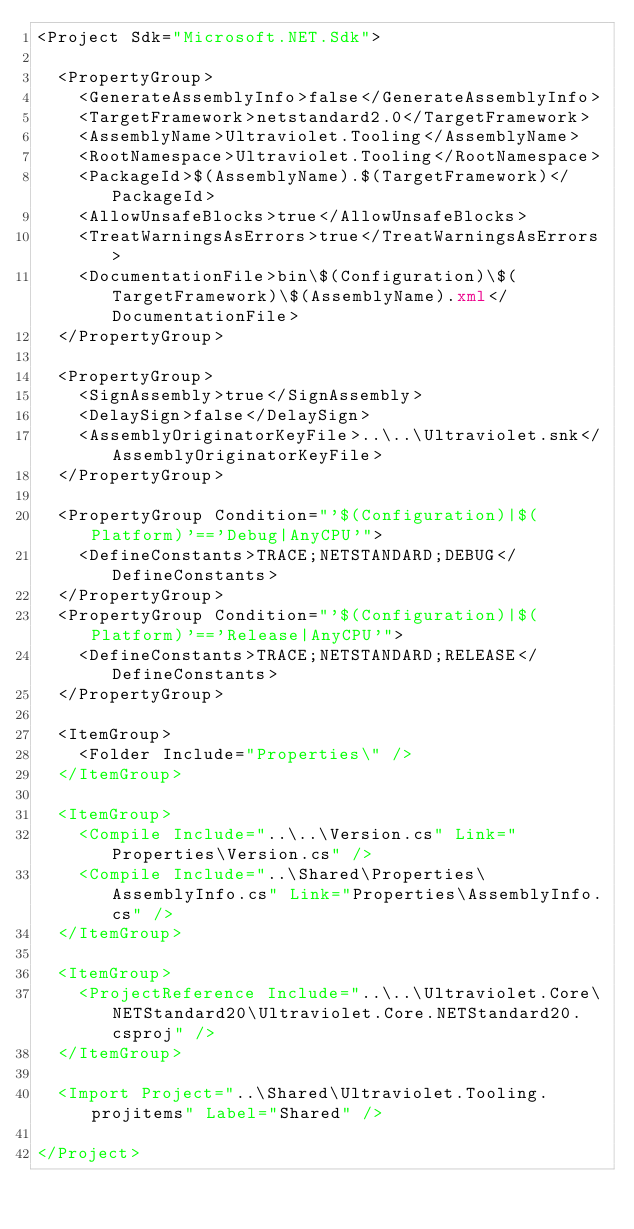Convert code to text. <code><loc_0><loc_0><loc_500><loc_500><_XML_><Project Sdk="Microsoft.NET.Sdk">

  <PropertyGroup>
    <GenerateAssemblyInfo>false</GenerateAssemblyInfo>
    <TargetFramework>netstandard2.0</TargetFramework>
    <AssemblyName>Ultraviolet.Tooling</AssemblyName>
    <RootNamespace>Ultraviolet.Tooling</RootNamespace>
    <PackageId>$(AssemblyName).$(TargetFramework)</PackageId>
    <AllowUnsafeBlocks>true</AllowUnsafeBlocks>
    <TreatWarningsAsErrors>true</TreatWarningsAsErrors>
    <DocumentationFile>bin\$(Configuration)\$(TargetFramework)\$(AssemblyName).xml</DocumentationFile>
  </PropertyGroup>

  <PropertyGroup>
    <SignAssembly>true</SignAssembly>
    <DelaySign>false</DelaySign>
    <AssemblyOriginatorKeyFile>..\..\Ultraviolet.snk</AssemblyOriginatorKeyFile>
  </PropertyGroup>

  <PropertyGroup Condition="'$(Configuration)|$(Platform)'=='Debug|AnyCPU'">
    <DefineConstants>TRACE;NETSTANDARD;DEBUG</DefineConstants>
  </PropertyGroup>
  <PropertyGroup Condition="'$(Configuration)|$(Platform)'=='Release|AnyCPU'">
    <DefineConstants>TRACE;NETSTANDARD;RELEASE</DefineConstants>
  </PropertyGroup>

  <ItemGroup>
    <Folder Include="Properties\" />
  </ItemGroup>

  <ItemGroup>
    <Compile Include="..\..\Version.cs" Link="Properties\Version.cs" />
    <Compile Include="..\Shared\Properties\AssemblyInfo.cs" Link="Properties\AssemblyInfo.cs" />
  </ItemGroup>

  <ItemGroup>
    <ProjectReference Include="..\..\Ultraviolet.Core\NETStandard20\Ultraviolet.Core.NETStandard20.csproj" />
  </ItemGroup>

  <Import Project="..\Shared\Ultraviolet.Tooling.projitems" Label="Shared" />

</Project>
</code> 